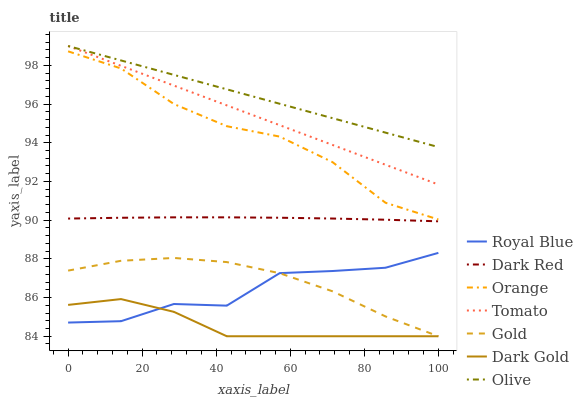Does Gold have the minimum area under the curve?
Answer yes or no. No. Does Gold have the maximum area under the curve?
Answer yes or no. No. Is Gold the smoothest?
Answer yes or no. No. Is Gold the roughest?
Answer yes or no. No. Does Olive have the lowest value?
Answer yes or no. No. Does Gold have the highest value?
Answer yes or no. No. Is Orange less than Tomato?
Answer yes or no. Yes. Is Olive greater than Dark Gold?
Answer yes or no. Yes. Does Orange intersect Tomato?
Answer yes or no. No. 